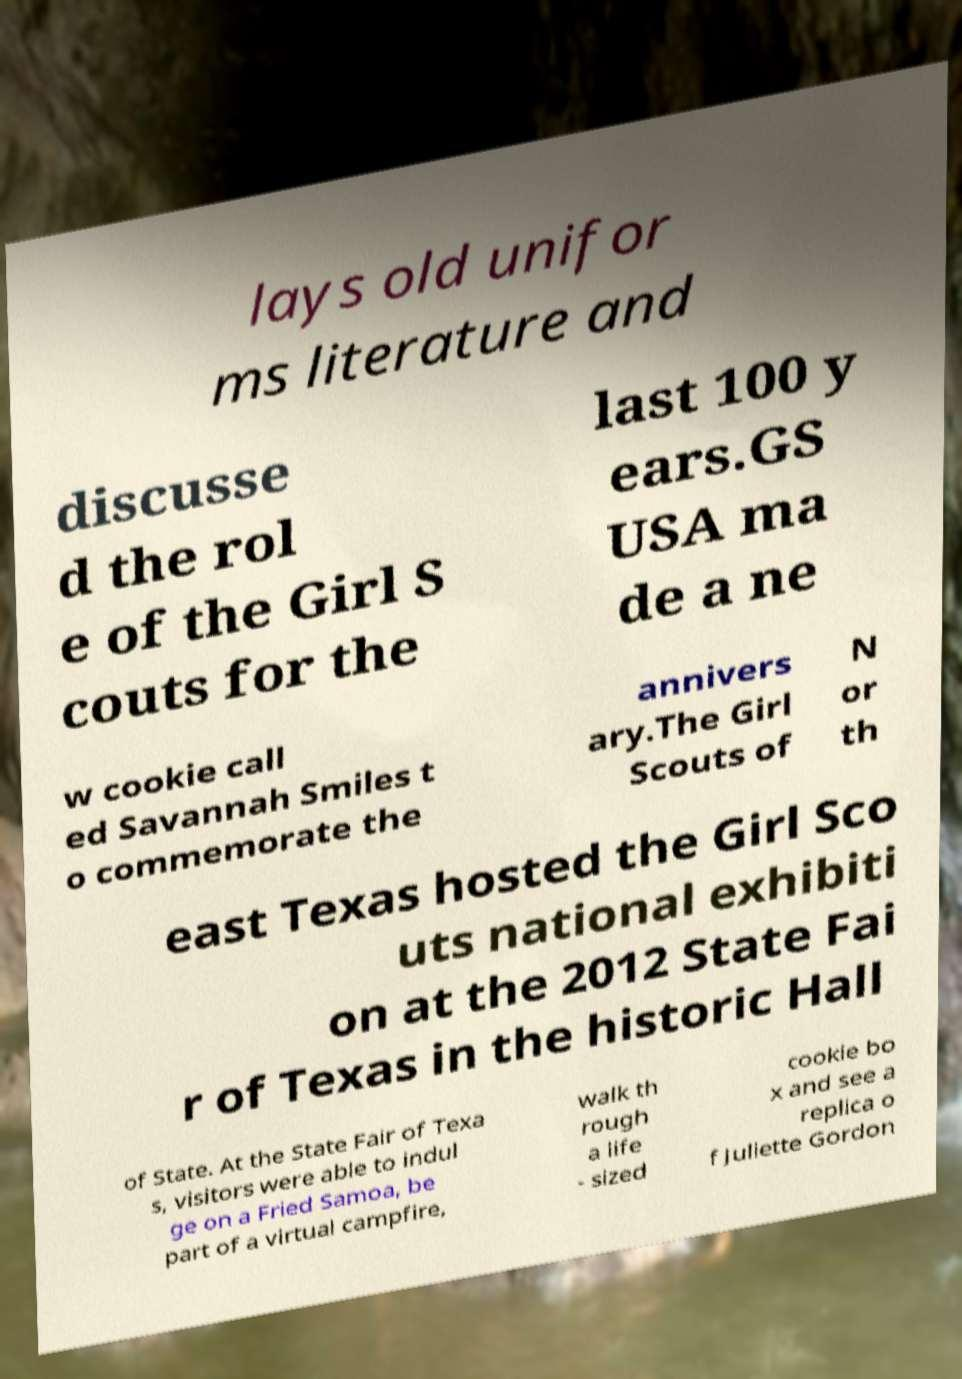Please identify and transcribe the text found in this image. lays old unifor ms literature and discusse d the rol e of the Girl S couts for the last 100 y ears.GS USA ma de a ne w cookie call ed Savannah Smiles t o commemorate the annivers ary.The Girl Scouts of N or th east Texas hosted the Girl Sco uts national exhibiti on at the 2012 State Fai r of Texas in the historic Hall of State. At the State Fair of Texa s, visitors were able to indul ge on a Fried Samoa, be part of a virtual campfire, walk th rough a life - sized cookie bo x and see a replica o f Juliette Gordon 